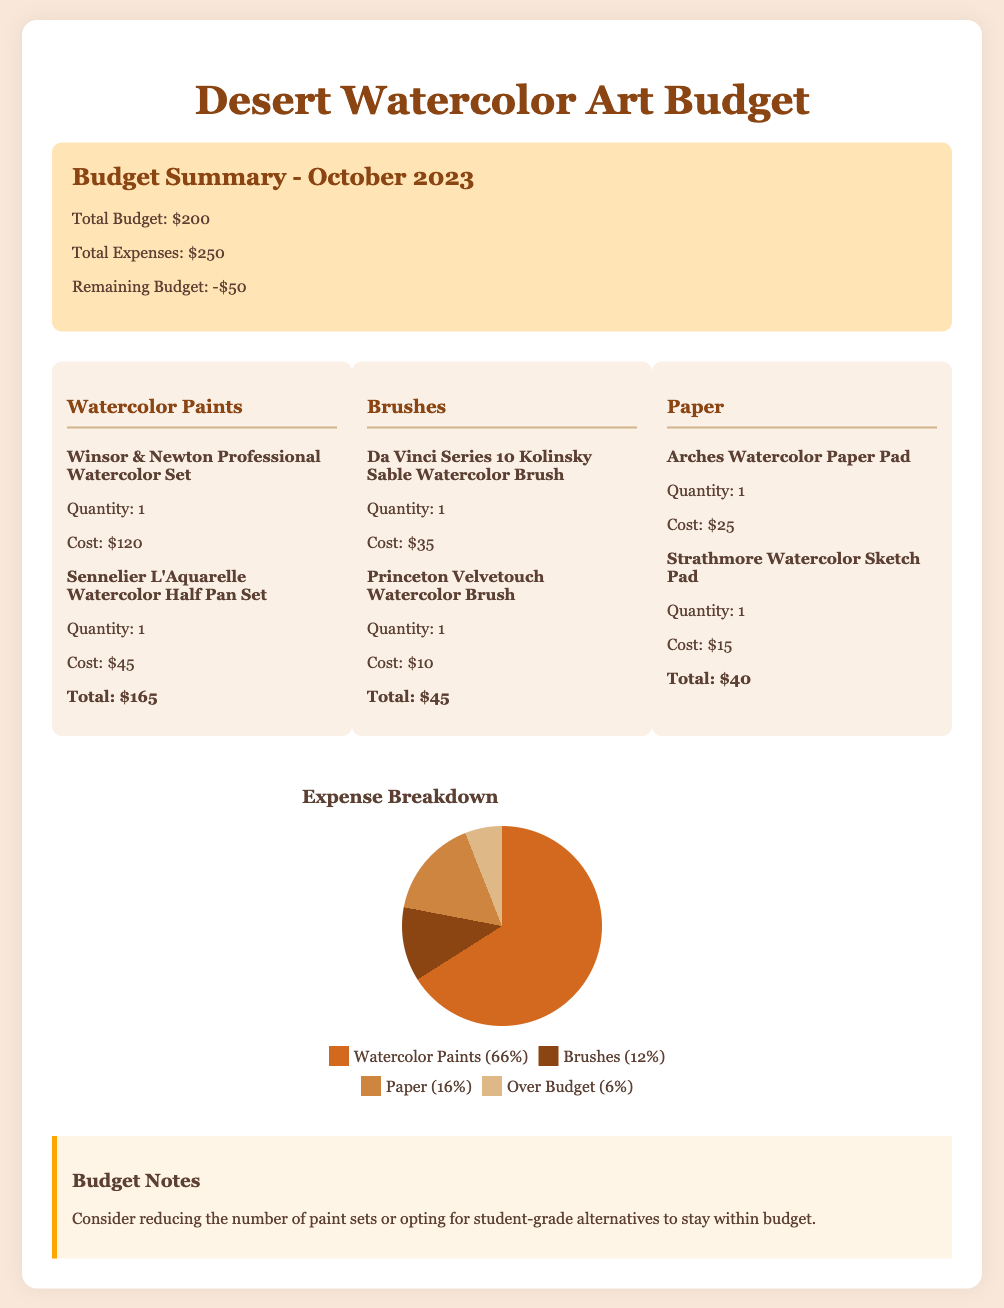What is the total budget? The total budget is stated clearly in the budget summary section of the document.
Answer: $200 What is the total expense? The total expenses are provided in the budget summary and include all categories of expenses combined.
Answer: $250 What is the cost of Winsor & Newton Professional Watercolor Set? This specific item cost is mentioned in the watercolor paints category section of the document.
Answer: $120 Which brush is the most expensive? Comparing all the brushes listed will provide the most expensive option, which is found in the brushes category.
Answer: Da Vinci Series 10 Kolinsky Sable Watercolor Brush What percentage of the budget is over? This percentage is indicated in the expense breakdown segment of the document.
Answer: 6% What is the total cost for watercolor paper? The total cost for paper is calculated by adding the costs of the two items in the paper category.
Answer: $40 How much has been spent on brushes? The total cost for brushes can be found by reviewing the brush expense section, which summarizes all items within that category.
Answer: $45 What color represents watercolor paints in the chart? The pie chart includes color coding for each category, and this question retrieves the specific color for paints.
Answer: #d2691e What is one suggestion mentioned in the budget notes? The budget notes section offers advice on how to manage expenses better to meet the budget.
Answer: Reduce the number of paint sets 